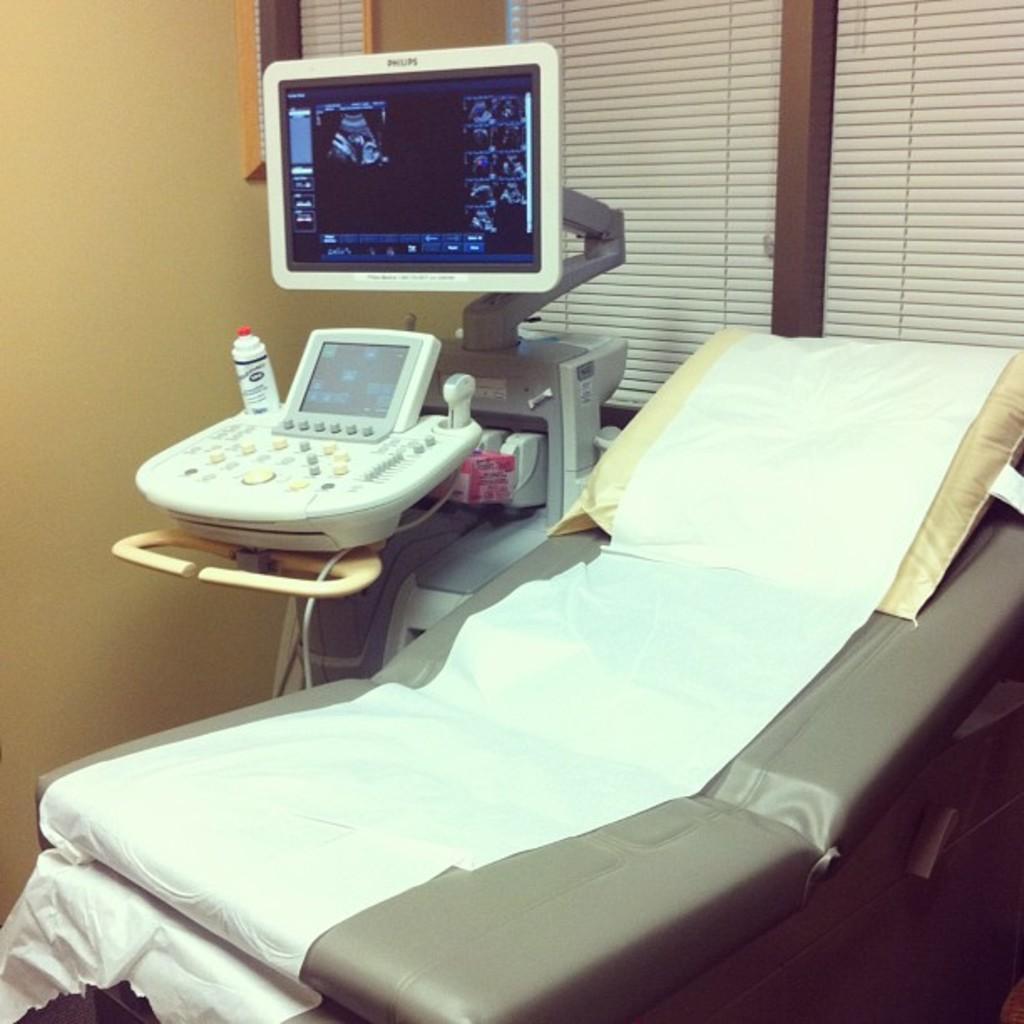Please provide a concise description of this image. In this image we can see a bed with a pillow on it. We can also see the monitor screen and some devices placed on the stand. On the backside we can see a wall and the window blinds. 